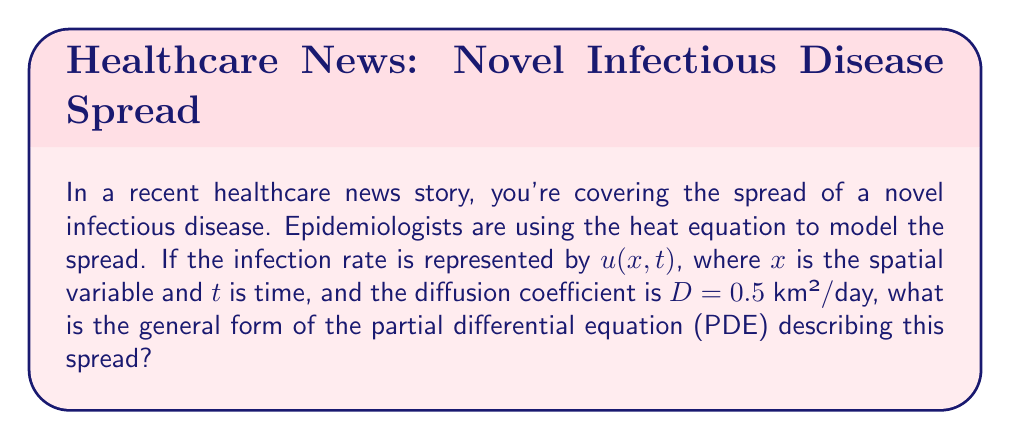Teach me how to tackle this problem. To model the spread of an infectious disease using the heat equation, we follow these steps:

1) The heat equation in its general form is:

   $$\frac{\partial u}{\partial t} = D \nabla^2 u$$

   where $u$ is the quantity being diffused (in this case, the infection rate), $t$ is time, $D$ is the diffusion coefficient, and $\nabla^2$ is the Laplacian operator.

2) In one spatial dimension, the Laplacian operator is simply the second partial derivative with respect to $x$:

   $$\nabla^2 u = \frac{\partial^2 u}{\partial x^2}$$

3) Substituting this into the heat equation:

   $$\frac{\partial u}{\partial t} = D \frac{\partial^2 u}{\partial x^2}$$

4) We're given that $D = 0.5$ km²/day. Substituting this value:

   $$\frac{\partial u}{\partial t} = 0.5 \frac{\partial^2 u}{\partial x^2}$$

This is the final form of the PDE describing the spread of the infectious disease.
Answer: $$\frac{\partial u}{\partial t} = 0.5 \frac{\partial^2 u}{\partial x^2}$$ 